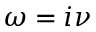Convert formula to latex. <formula><loc_0><loc_0><loc_500><loc_500>\omega = i \nu</formula> 